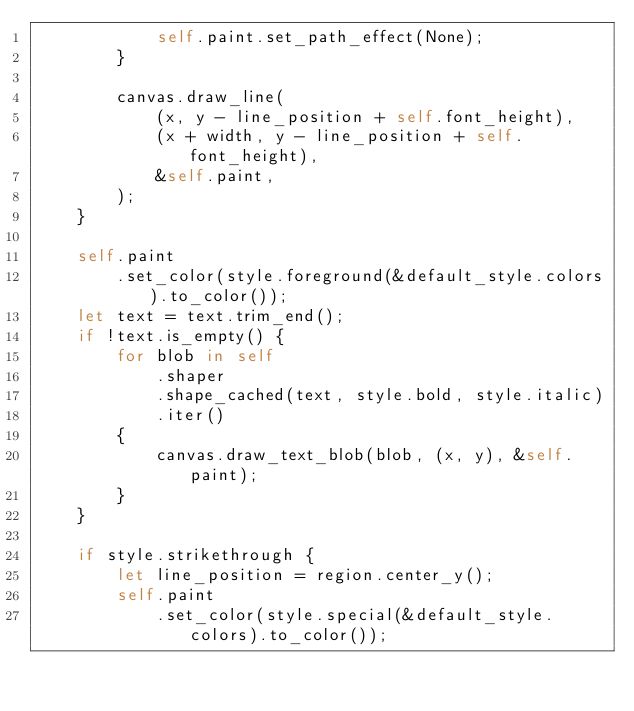Convert code to text. <code><loc_0><loc_0><loc_500><loc_500><_Rust_>            self.paint.set_path_effect(None);
        }

        canvas.draw_line(
            (x, y - line_position + self.font_height),
            (x + width, y - line_position + self.font_height),
            &self.paint,
        );
    }

    self.paint
        .set_color(style.foreground(&default_style.colors).to_color());
    let text = text.trim_end();
    if !text.is_empty() {
        for blob in self
            .shaper
            .shape_cached(text, style.bold, style.italic)
            .iter()
        {
            canvas.draw_text_blob(blob, (x, y), &self.paint);
        }
    }

    if style.strikethrough {
        let line_position = region.center_y();
        self.paint
            .set_color(style.special(&default_style.colors).to_color());</code> 